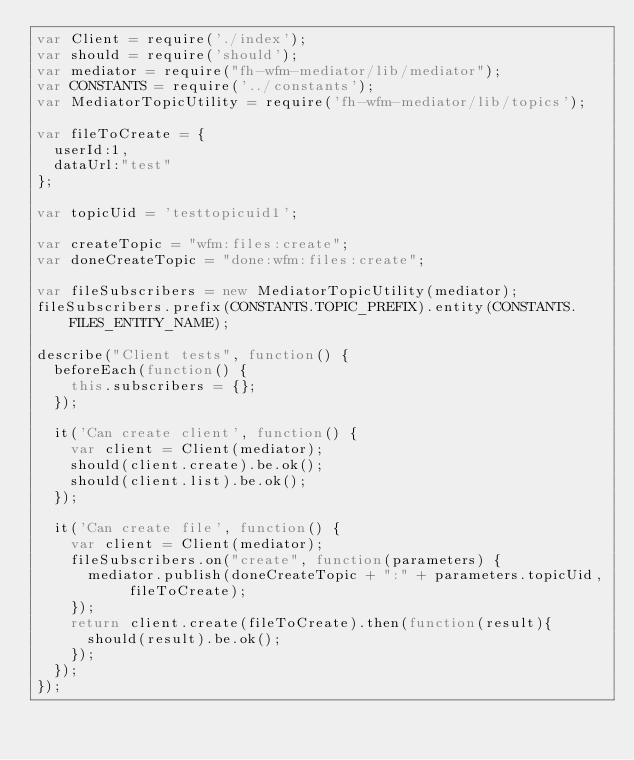Convert code to text. <code><loc_0><loc_0><loc_500><loc_500><_JavaScript_>var Client = require('./index');
var should = require('should');
var mediator = require("fh-wfm-mediator/lib/mediator");
var CONSTANTS = require('../constants');
var MediatorTopicUtility = require('fh-wfm-mediator/lib/topics');

var fileToCreate = {
  userId:1,
  dataUrl:"test"
};

var topicUid = 'testtopicuid1';

var createTopic = "wfm:files:create";
var doneCreateTopic = "done:wfm:files:create";

var fileSubscribers = new MediatorTopicUtility(mediator);
fileSubscribers.prefix(CONSTANTS.TOPIC_PREFIX).entity(CONSTANTS.FILES_ENTITY_NAME);

describe("Client tests", function() {
  beforeEach(function() {
    this.subscribers = {};
  });
  
  it('Can create client', function() {
    var client = Client(mediator);
    should(client.create).be.ok();
    should(client.list).be.ok();
  });
  
  it('Can create file', function() {
    var client = Client(mediator);
    fileSubscribers.on("create", function(parameters) {
      mediator.publish(doneCreateTopic + ":" + parameters.topicUid, fileToCreate);
    });
    return client.create(fileToCreate).then(function(result){
      should(result).be.ok();
    });
  });
});</code> 